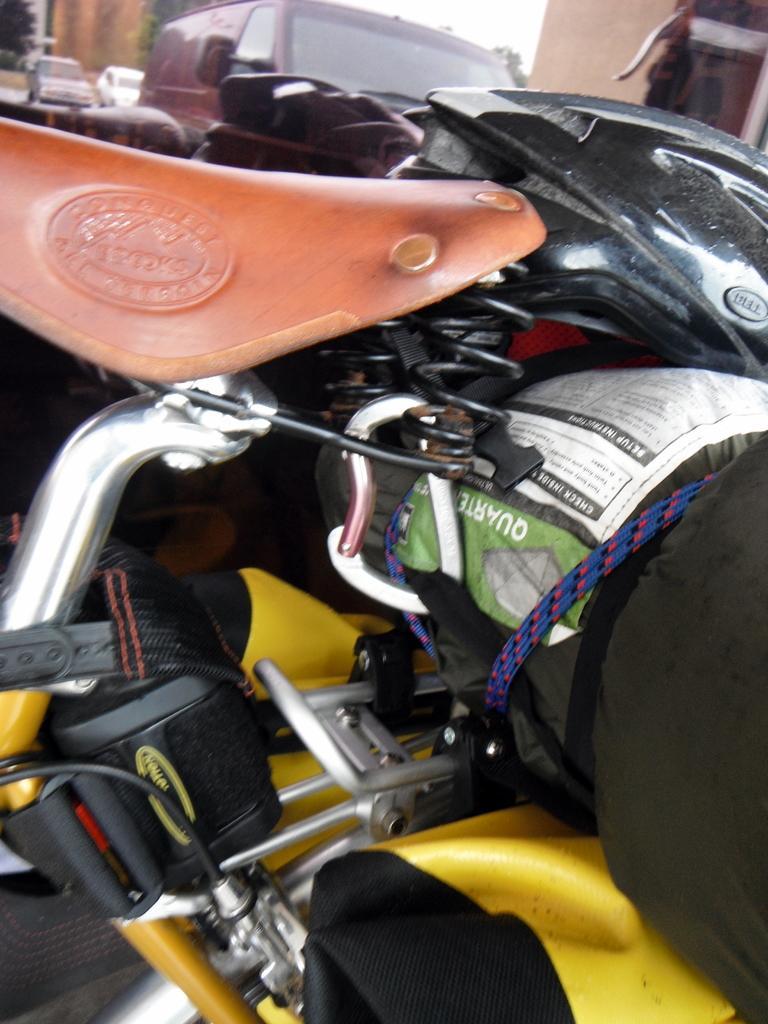Could you give a brief overview of what you see in this image? We can see cloth is tied with a rope to the bicycle and on the cloth we can see a helmet. In the background there are trees, vehicles, wall and sky. 